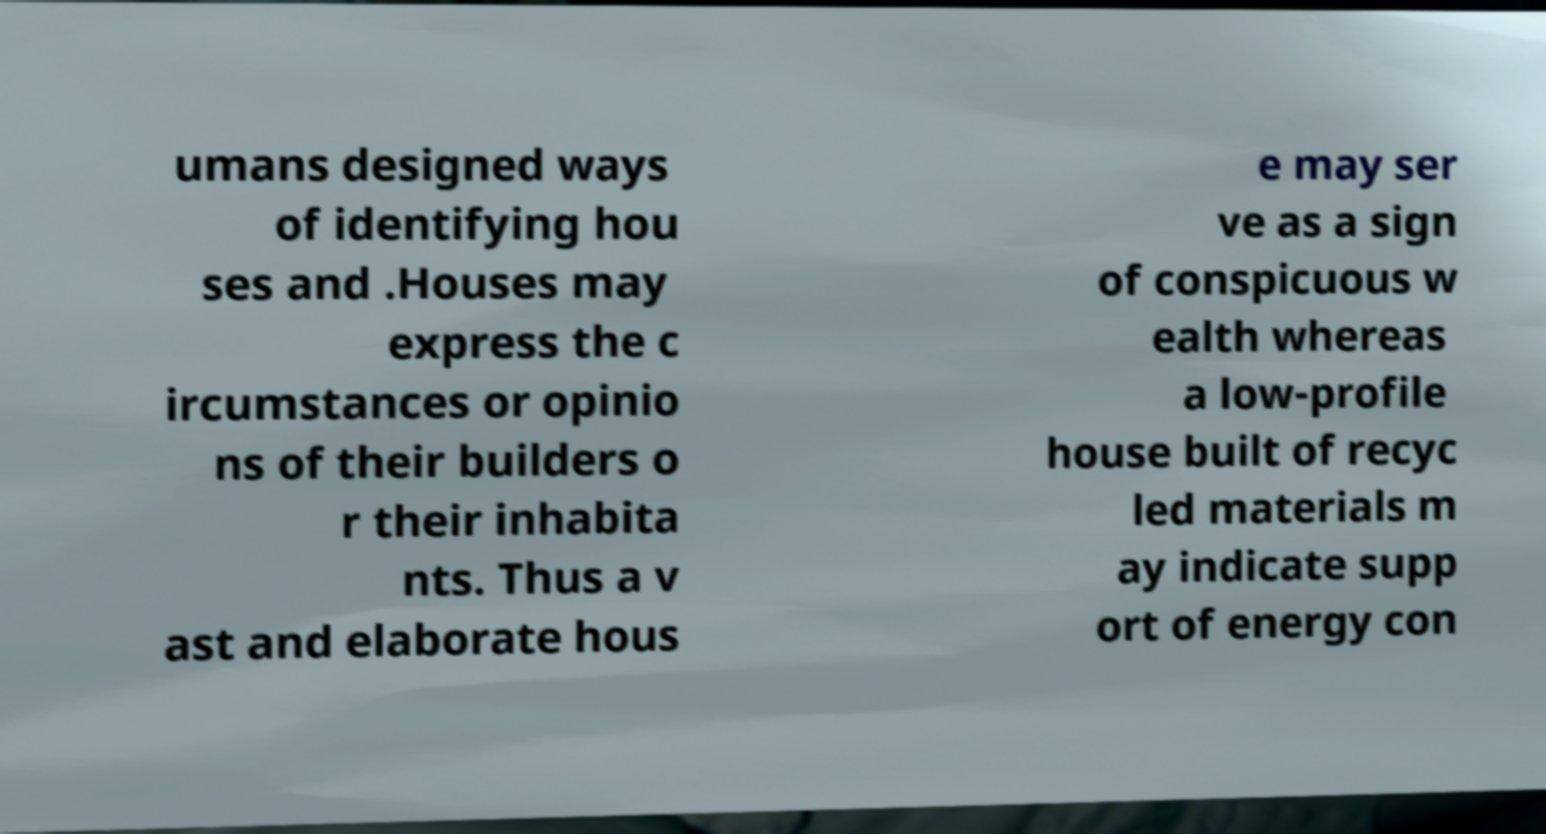Can you read and provide the text displayed in the image?This photo seems to have some interesting text. Can you extract and type it out for me? umans designed ways of identifying hou ses and .Houses may express the c ircumstances or opinio ns of their builders o r their inhabita nts. Thus a v ast and elaborate hous e may ser ve as a sign of conspicuous w ealth whereas a low-profile house built of recyc led materials m ay indicate supp ort of energy con 